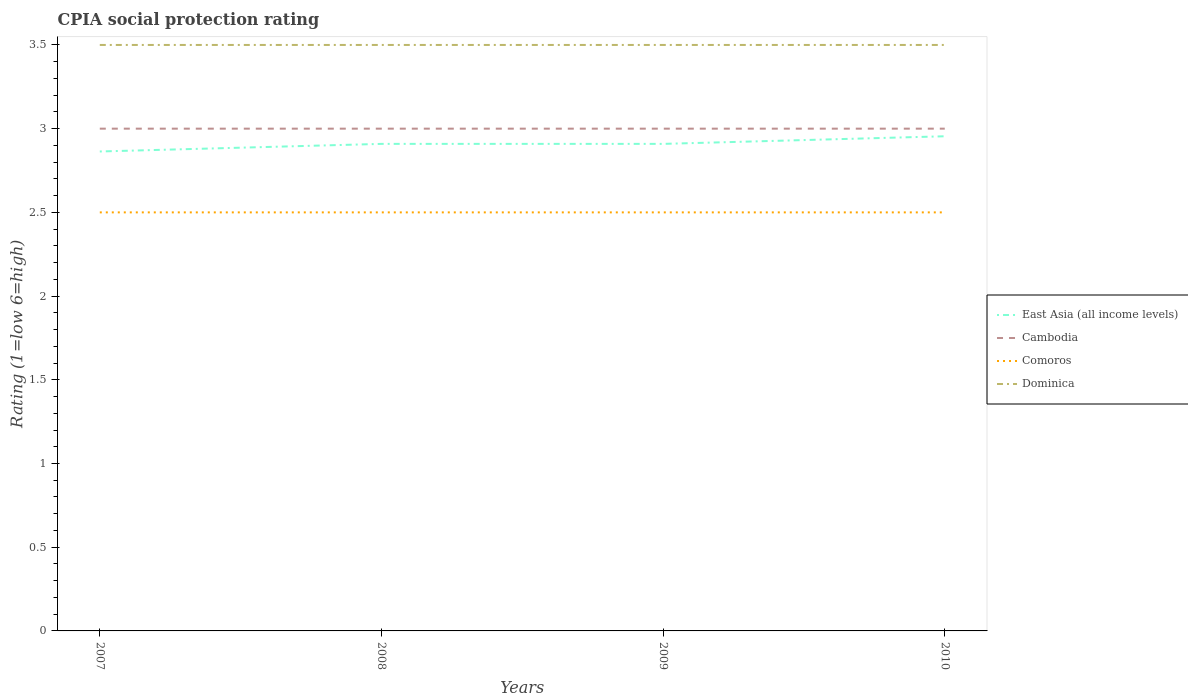Does the line corresponding to East Asia (all income levels) intersect with the line corresponding to Comoros?
Make the answer very short. No. Is the number of lines equal to the number of legend labels?
Keep it short and to the point. Yes. Across all years, what is the maximum CPIA rating in Comoros?
Provide a succinct answer. 2.5. In which year was the CPIA rating in Dominica maximum?
Provide a short and direct response. 2007. What is the difference between the highest and the lowest CPIA rating in Cambodia?
Your response must be concise. 0. How many years are there in the graph?
Offer a terse response. 4. How many legend labels are there?
Offer a very short reply. 4. What is the title of the graph?
Give a very brief answer. CPIA social protection rating. Does "Lesotho" appear as one of the legend labels in the graph?
Your answer should be compact. No. What is the Rating (1=low 6=high) of East Asia (all income levels) in 2007?
Ensure brevity in your answer.  2.86. What is the Rating (1=low 6=high) in Cambodia in 2007?
Provide a succinct answer. 3. What is the Rating (1=low 6=high) in Comoros in 2007?
Your response must be concise. 2.5. What is the Rating (1=low 6=high) of East Asia (all income levels) in 2008?
Provide a succinct answer. 2.91. What is the Rating (1=low 6=high) of Comoros in 2008?
Ensure brevity in your answer.  2.5. What is the Rating (1=low 6=high) in East Asia (all income levels) in 2009?
Your answer should be compact. 2.91. What is the Rating (1=low 6=high) of Comoros in 2009?
Ensure brevity in your answer.  2.5. What is the Rating (1=low 6=high) in East Asia (all income levels) in 2010?
Your answer should be compact. 2.95. What is the Rating (1=low 6=high) in Cambodia in 2010?
Provide a short and direct response. 3. Across all years, what is the maximum Rating (1=low 6=high) of East Asia (all income levels)?
Keep it short and to the point. 2.95. Across all years, what is the maximum Rating (1=low 6=high) of Cambodia?
Make the answer very short. 3. Across all years, what is the maximum Rating (1=low 6=high) of Dominica?
Your answer should be compact. 3.5. Across all years, what is the minimum Rating (1=low 6=high) in East Asia (all income levels)?
Offer a very short reply. 2.86. Across all years, what is the minimum Rating (1=low 6=high) in Comoros?
Offer a terse response. 2.5. Across all years, what is the minimum Rating (1=low 6=high) in Dominica?
Offer a terse response. 3.5. What is the total Rating (1=low 6=high) of East Asia (all income levels) in the graph?
Provide a short and direct response. 11.64. What is the total Rating (1=low 6=high) of Dominica in the graph?
Your answer should be very brief. 14. What is the difference between the Rating (1=low 6=high) of East Asia (all income levels) in 2007 and that in 2008?
Provide a short and direct response. -0.05. What is the difference between the Rating (1=low 6=high) of Dominica in 2007 and that in 2008?
Provide a short and direct response. 0. What is the difference between the Rating (1=low 6=high) in East Asia (all income levels) in 2007 and that in 2009?
Offer a terse response. -0.05. What is the difference between the Rating (1=low 6=high) in East Asia (all income levels) in 2007 and that in 2010?
Your answer should be compact. -0.09. What is the difference between the Rating (1=low 6=high) of Cambodia in 2007 and that in 2010?
Provide a short and direct response. 0. What is the difference between the Rating (1=low 6=high) in Dominica in 2007 and that in 2010?
Give a very brief answer. 0. What is the difference between the Rating (1=low 6=high) in Cambodia in 2008 and that in 2009?
Offer a very short reply. 0. What is the difference between the Rating (1=low 6=high) of Dominica in 2008 and that in 2009?
Ensure brevity in your answer.  0. What is the difference between the Rating (1=low 6=high) of East Asia (all income levels) in 2008 and that in 2010?
Your response must be concise. -0.05. What is the difference between the Rating (1=low 6=high) in Dominica in 2008 and that in 2010?
Your response must be concise. 0. What is the difference between the Rating (1=low 6=high) in East Asia (all income levels) in 2009 and that in 2010?
Offer a terse response. -0.05. What is the difference between the Rating (1=low 6=high) of Cambodia in 2009 and that in 2010?
Your answer should be very brief. 0. What is the difference between the Rating (1=low 6=high) in East Asia (all income levels) in 2007 and the Rating (1=low 6=high) in Cambodia in 2008?
Provide a succinct answer. -0.14. What is the difference between the Rating (1=low 6=high) of East Asia (all income levels) in 2007 and the Rating (1=low 6=high) of Comoros in 2008?
Your response must be concise. 0.36. What is the difference between the Rating (1=low 6=high) of East Asia (all income levels) in 2007 and the Rating (1=low 6=high) of Dominica in 2008?
Offer a very short reply. -0.64. What is the difference between the Rating (1=low 6=high) in Cambodia in 2007 and the Rating (1=low 6=high) in Dominica in 2008?
Provide a succinct answer. -0.5. What is the difference between the Rating (1=low 6=high) of Comoros in 2007 and the Rating (1=low 6=high) of Dominica in 2008?
Offer a terse response. -1. What is the difference between the Rating (1=low 6=high) of East Asia (all income levels) in 2007 and the Rating (1=low 6=high) of Cambodia in 2009?
Make the answer very short. -0.14. What is the difference between the Rating (1=low 6=high) in East Asia (all income levels) in 2007 and the Rating (1=low 6=high) in Comoros in 2009?
Your answer should be compact. 0.36. What is the difference between the Rating (1=low 6=high) in East Asia (all income levels) in 2007 and the Rating (1=low 6=high) in Dominica in 2009?
Provide a short and direct response. -0.64. What is the difference between the Rating (1=low 6=high) of Comoros in 2007 and the Rating (1=low 6=high) of Dominica in 2009?
Your answer should be very brief. -1. What is the difference between the Rating (1=low 6=high) in East Asia (all income levels) in 2007 and the Rating (1=low 6=high) in Cambodia in 2010?
Provide a short and direct response. -0.14. What is the difference between the Rating (1=low 6=high) of East Asia (all income levels) in 2007 and the Rating (1=low 6=high) of Comoros in 2010?
Provide a succinct answer. 0.36. What is the difference between the Rating (1=low 6=high) of East Asia (all income levels) in 2007 and the Rating (1=low 6=high) of Dominica in 2010?
Offer a very short reply. -0.64. What is the difference between the Rating (1=low 6=high) in Cambodia in 2007 and the Rating (1=low 6=high) in Comoros in 2010?
Make the answer very short. 0.5. What is the difference between the Rating (1=low 6=high) of Comoros in 2007 and the Rating (1=low 6=high) of Dominica in 2010?
Ensure brevity in your answer.  -1. What is the difference between the Rating (1=low 6=high) in East Asia (all income levels) in 2008 and the Rating (1=low 6=high) in Cambodia in 2009?
Your answer should be very brief. -0.09. What is the difference between the Rating (1=low 6=high) in East Asia (all income levels) in 2008 and the Rating (1=low 6=high) in Comoros in 2009?
Your response must be concise. 0.41. What is the difference between the Rating (1=low 6=high) of East Asia (all income levels) in 2008 and the Rating (1=low 6=high) of Dominica in 2009?
Your answer should be very brief. -0.59. What is the difference between the Rating (1=low 6=high) in Cambodia in 2008 and the Rating (1=low 6=high) in Dominica in 2009?
Keep it short and to the point. -0.5. What is the difference between the Rating (1=low 6=high) in East Asia (all income levels) in 2008 and the Rating (1=low 6=high) in Cambodia in 2010?
Offer a very short reply. -0.09. What is the difference between the Rating (1=low 6=high) of East Asia (all income levels) in 2008 and the Rating (1=low 6=high) of Comoros in 2010?
Your response must be concise. 0.41. What is the difference between the Rating (1=low 6=high) of East Asia (all income levels) in 2008 and the Rating (1=low 6=high) of Dominica in 2010?
Make the answer very short. -0.59. What is the difference between the Rating (1=low 6=high) of East Asia (all income levels) in 2009 and the Rating (1=low 6=high) of Cambodia in 2010?
Ensure brevity in your answer.  -0.09. What is the difference between the Rating (1=low 6=high) in East Asia (all income levels) in 2009 and the Rating (1=low 6=high) in Comoros in 2010?
Make the answer very short. 0.41. What is the difference between the Rating (1=low 6=high) of East Asia (all income levels) in 2009 and the Rating (1=low 6=high) of Dominica in 2010?
Keep it short and to the point. -0.59. What is the difference between the Rating (1=low 6=high) in Cambodia in 2009 and the Rating (1=low 6=high) in Comoros in 2010?
Ensure brevity in your answer.  0.5. What is the difference between the Rating (1=low 6=high) in Comoros in 2009 and the Rating (1=low 6=high) in Dominica in 2010?
Ensure brevity in your answer.  -1. What is the average Rating (1=low 6=high) in East Asia (all income levels) per year?
Your answer should be compact. 2.91. What is the average Rating (1=low 6=high) of Comoros per year?
Keep it short and to the point. 2.5. In the year 2007, what is the difference between the Rating (1=low 6=high) in East Asia (all income levels) and Rating (1=low 6=high) in Cambodia?
Provide a succinct answer. -0.14. In the year 2007, what is the difference between the Rating (1=low 6=high) in East Asia (all income levels) and Rating (1=low 6=high) in Comoros?
Offer a terse response. 0.36. In the year 2007, what is the difference between the Rating (1=low 6=high) in East Asia (all income levels) and Rating (1=low 6=high) in Dominica?
Provide a succinct answer. -0.64. In the year 2007, what is the difference between the Rating (1=low 6=high) of Cambodia and Rating (1=low 6=high) of Comoros?
Make the answer very short. 0.5. In the year 2007, what is the difference between the Rating (1=low 6=high) in Cambodia and Rating (1=low 6=high) in Dominica?
Offer a terse response. -0.5. In the year 2008, what is the difference between the Rating (1=low 6=high) of East Asia (all income levels) and Rating (1=low 6=high) of Cambodia?
Make the answer very short. -0.09. In the year 2008, what is the difference between the Rating (1=low 6=high) in East Asia (all income levels) and Rating (1=low 6=high) in Comoros?
Your answer should be very brief. 0.41. In the year 2008, what is the difference between the Rating (1=low 6=high) in East Asia (all income levels) and Rating (1=low 6=high) in Dominica?
Provide a succinct answer. -0.59. In the year 2009, what is the difference between the Rating (1=low 6=high) in East Asia (all income levels) and Rating (1=low 6=high) in Cambodia?
Keep it short and to the point. -0.09. In the year 2009, what is the difference between the Rating (1=low 6=high) of East Asia (all income levels) and Rating (1=low 6=high) of Comoros?
Your answer should be very brief. 0.41. In the year 2009, what is the difference between the Rating (1=low 6=high) of East Asia (all income levels) and Rating (1=low 6=high) of Dominica?
Your answer should be very brief. -0.59. In the year 2009, what is the difference between the Rating (1=low 6=high) in Cambodia and Rating (1=low 6=high) in Comoros?
Your answer should be compact. 0.5. In the year 2009, what is the difference between the Rating (1=low 6=high) in Cambodia and Rating (1=low 6=high) in Dominica?
Provide a short and direct response. -0.5. In the year 2009, what is the difference between the Rating (1=low 6=high) in Comoros and Rating (1=low 6=high) in Dominica?
Your answer should be compact. -1. In the year 2010, what is the difference between the Rating (1=low 6=high) in East Asia (all income levels) and Rating (1=low 6=high) in Cambodia?
Your response must be concise. -0.05. In the year 2010, what is the difference between the Rating (1=low 6=high) in East Asia (all income levels) and Rating (1=low 6=high) in Comoros?
Ensure brevity in your answer.  0.45. In the year 2010, what is the difference between the Rating (1=low 6=high) in East Asia (all income levels) and Rating (1=low 6=high) in Dominica?
Give a very brief answer. -0.55. In the year 2010, what is the difference between the Rating (1=low 6=high) in Cambodia and Rating (1=low 6=high) in Comoros?
Give a very brief answer. 0.5. In the year 2010, what is the difference between the Rating (1=low 6=high) of Cambodia and Rating (1=low 6=high) of Dominica?
Offer a terse response. -0.5. What is the ratio of the Rating (1=low 6=high) in East Asia (all income levels) in 2007 to that in 2008?
Keep it short and to the point. 0.98. What is the ratio of the Rating (1=low 6=high) of Cambodia in 2007 to that in 2008?
Provide a short and direct response. 1. What is the ratio of the Rating (1=low 6=high) in Comoros in 2007 to that in 2008?
Make the answer very short. 1. What is the ratio of the Rating (1=low 6=high) of Dominica in 2007 to that in 2008?
Offer a terse response. 1. What is the ratio of the Rating (1=low 6=high) in East Asia (all income levels) in 2007 to that in 2009?
Make the answer very short. 0.98. What is the ratio of the Rating (1=low 6=high) in Cambodia in 2007 to that in 2009?
Offer a terse response. 1. What is the ratio of the Rating (1=low 6=high) in Comoros in 2007 to that in 2009?
Offer a very short reply. 1. What is the ratio of the Rating (1=low 6=high) in Dominica in 2007 to that in 2009?
Offer a very short reply. 1. What is the ratio of the Rating (1=low 6=high) in East Asia (all income levels) in 2007 to that in 2010?
Offer a very short reply. 0.97. What is the ratio of the Rating (1=low 6=high) in Comoros in 2007 to that in 2010?
Provide a succinct answer. 1. What is the ratio of the Rating (1=low 6=high) in East Asia (all income levels) in 2008 to that in 2009?
Ensure brevity in your answer.  1. What is the ratio of the Rating (1=low 6=high) in East Asia (all income levels) in 2008 to that in 2010?
Ensure brevity in your answer.  0.98. What is the ratio of the Rating (1=low 6=high) of Comoros in 2008 to that in 2010?
Ensure brevity in your answer.  1. What is the ratio of the Rating (1=low 6=high) in East Asia (all income levels) in 2009 to that in 2010?
Provide a short and direct response. 0.98. What is the difference between the highest and the second highest Rating (1=low 6=high) of East Asia (all income levels)?
Provide a succinct answer. 0.05. What is the difference between the highest and the second highest Rating (1=low 6=high) of Cambodia?
Keep it short and to the point. 0. What is the difference between the highest and the second highest Rating (1=low 6=high) of Comoros?
Ensure brevity in your answer.  0. What is the difference between the highest and the second highest Rating (1=low 6=high) in Dominica?
Offer a terse response. 0. What is the difference between the highest and the lowest Rating (1=low 6=high) of East Asia (all income levels)?
Provide a short and direct response. 0.09. What is the difference between the highest and the lowest Rating (1=low 6=high) of Dominica?
Provide a succinct answer. 0. 